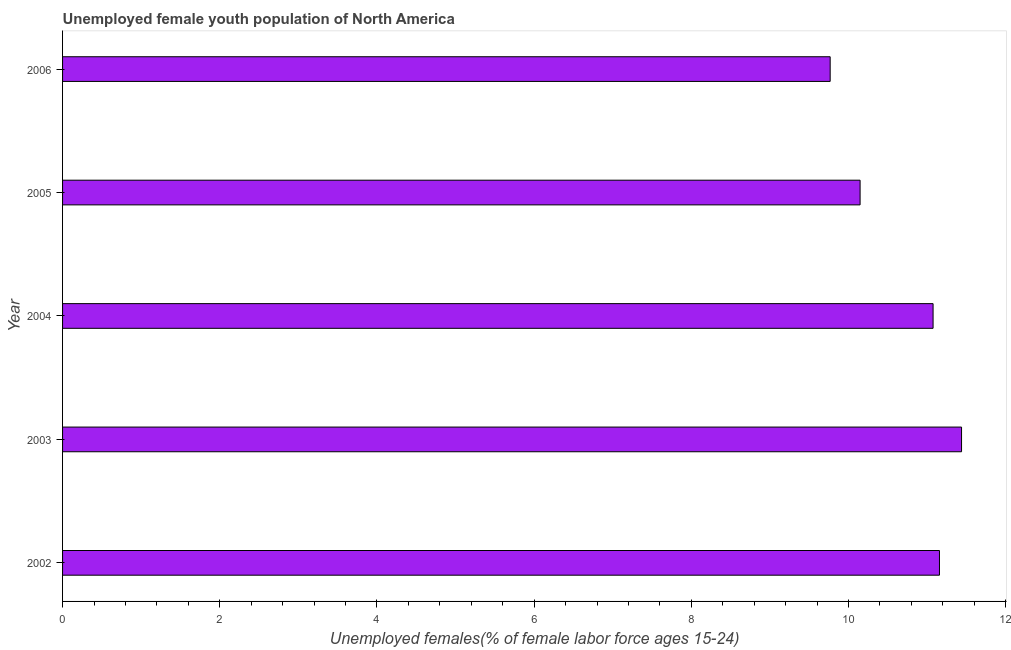What is the title of the graph?
Provide a short and direct response. Unemployed female youth population of North America. What is the label or title of the X-axis?
Your answer should be compact. Unemployed females(% of female labor force ages 15-24). What is the label or title of the Y-axis?
Give a very brief answer. Year. What is the unemployed female youth in 2006?
Offer a terse response. 9.77. Across all years, what is the maximum unemployed female youth?
Offer a very short reply. 11.44. Across all years, what is the minimum unemployed female youth?
Ensure brevity in your answer.  9.77. In which year was the unemployed female youth maximum?
Provide a short and direct response. 2003. What is the sum of the unemployed female youth?
Give a very brief answer. 53.59. What is the difference between the unemployed female youth in 2004 and 2006?
Your response must be concise. 1.31. What is the average unemployed female youth per year?
Provide a short and direct response. 10.72. What is the median unemployed female youth?
Your response must be concise. 11.08. In how many years, is the unemployed female youth greater than 8.8 %?
Offer a very short reply. 5. What is the ratio of the unemployed female youth in 2003 to that in 2004?
Offer a terse response. 1.03. Is the unemployed female youth in 2002 less than that in 2005?
Keep it short and to the point. No. Is the difference between the unemployed female youth in 2002 and 2003 greater than the difference between any two years?
Ensure brevity in your answer.  No. What is the difference between the highest and the second highest unemployed female youth?
Your answer should be compact. 0.28. Is the sum of the unemployed female youth in 2004 and 2006 greater than the maximum unemployed female youth across all years?
Keep it short and to the point. Yes. What is the difference between the highest and the lowest unemployed female youth?
Give a very brief answer. 1.67. In how many years, is the unemployed female youth greater than the average unemployed female youth taken over all years?
Make the answer very short. 3. How many years are there in the graph?
Your response must be concise. 5. What is the difference between two consecutive major ticks on the X-axis?
Keep it short and to the point. 2. What is the Unemployed females(% of female labor force ages 15-24) of 2002?
Ensure brevity in your answer.  11.16. What is the Unemployed females(% of female labor force ages 15-24) of 2003?
Your answer should be compact. 11.44. What is the Unemployed females(% of female labor force ages 15-24) in 2004?
Your response must be concise. 11.08. What is the Unemployed females(% of female labor force ages 15-24) of 2005?
Make the answer very short. 10.15. What is the Unemployed females(% of female labor force ages 15-24) in 2006?
Your answer should be very brief. 9.77. What is the difference between the Unemployed females(% of female labor force ages 15-24) in 2002 and 2003?
Ensure brevity in your answer.  -0.28. What is the difference between the Unemployed females(% of female labor force ages 15-24) in 2002 and 2004?
Keep it short and to the point. 0.08. What is the difference between the Unemployed females(% of female labor force ages 15-24) in 2002 and 2005?
Keep it short and to the point. 1.01. What is the difference between the Unemployed females(% of female labor force ages 15-24) in 2002 and 2006?
Provide a short and direct response. 1.39. What is the difference between the Unemployed females(% of female labor force ages 15-24) in 2003 and 2004?
Your answer should be very brief. 0.36. What is the difference between the Unemployed females(% of female labor force ages 15-24) in 2003 and 2005?
Your answer should be very brief. 1.29. What is the difference between the Unemployed females(% of female labor force ages 15-24) in 2003 and 2006?
Make the answer very short. 1.67. What is the difference between the Unemployed females(% of female labor force ages 15-24) in 2004 and 2005?
Offer a very short reply. 0.93. What is the difference between the Unemployed females(% of female labor force ages 15-24) in 2004 and 2006?
Ensure brevity in your answer.  1.31. What is the difference between the Unemployed females(% of female labor force ages 15-24) in 2005 and 2006?
Offer a terse response. 0.38. What is the ratio of the Unemployed females(% of female labor force ages 15-24) in 2002 to that in 2003?
Your response must be concise. 0.97. What is the ratio of the Unemployed females(% of female labor force ages 15-24) in 2002 to that in 2004?
Offer a very short reply. 1.01. What is the ratio of the Unemployed females(% of female labor force ages 15-24) in 2002 to that in 2005?
Your answer should be compact. 1.1. What is the ratio of the Unemployed females(% of female labor force ages 15-24) in 2002 to that in 2006?
Ensure brevity in your answer.  1.14. What is the ratio of the Unemployed females(% of female labor force ages 15-24) in 2003 to that in 2004?
Your response must be concise. 1.03. What is the ratio of the Unemployed females(% of female labor force ages 15-24) in 2003 to that in 2005?
Give a very brief answer. 1.13. What is the ratio of the Unemployed females(% of female labor force ages 15-24) in 2003 to that in 2006?
Your response must be concise. 1.17. What is the ratio of the Unemployed females(% of female labor force ages 15-24) in 2004 to that in 2005?
Your answer should be compact. 1.09. What is the ratio of the Unemployed females(% of female labor force ages 15-24) in 2004 to that in 2006?
Offer a terse response. 1.13. What is the ratio of the Unemployed females(% of female labor force ages 15-24) in 2005 to that in 2006?
Provide a succinct answer. 1.04. 